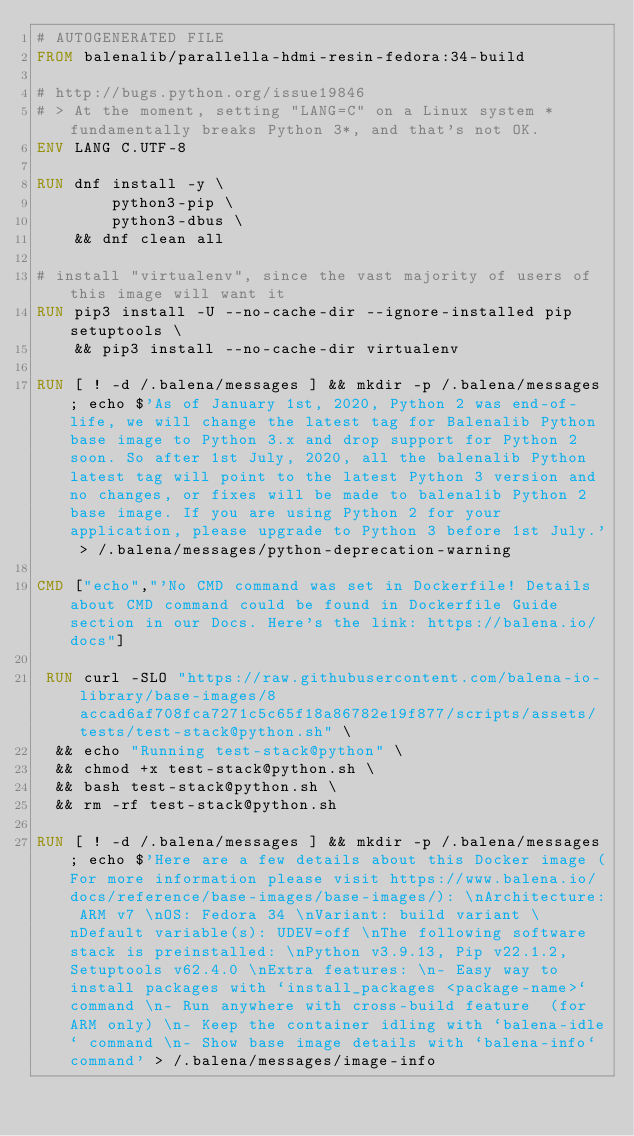<code> <loc_0><loc_0><loc_500><loc_500><_Dockerfile_># AUTOGENERATED FILE
FROM balenalib/parallella-hdmi-resin-fedora:34-build

# http://bugs.python.org/issue19846
# > At the moment, setting "LANG=C" on a Linux system *fundamentally breaks Python 3*, and that's not OK.
ENV LANG C.UTF-8

RUN dnf install -y \
		python3-pip \
		python3-dbus \
	&& dnf clean all

# install "virtualenv", since the vast majority of users of this image will want it
RUN pip3 install -U --no-cache-dir --ignore-installed pip setuptools \
	&& pip3 install --no-cache-dir virtualenv

RUN [ ! -d /.balena/messages ] && mkdir -p /.balena/messages; echo $'As of January 1st, 2020, Python 2 was end-of-life, we will change the latest tag for Balenalib Python base image to Python 3.x and drop support for Python 2 soon. So after 1st July, 2020, all the balenalib Python latest tag will point to the latest Python 3 version and no changes, or fixes will be made to balenalib Python 2 base image. If you are using Python 2 for your application, please upgrade to Python 3 before 1st July.' > /.balena/messages/python-deprecation-warning

CMD ["echo","'No CMD command was set in Dockerfile! Details about CMD command could be found in Dockerfile Guide section in our Docs. Here's the link: https://balena.io/docs"]

 RUN curl -SLO "https://raw.githubusercontent.com/balena-io-library/base-images/8accad6af708fca7271c5c65f18a86782e19f877/scripts/assets/tests/test-stack@python.sh" \
  && echo "Running test-stack@python" \
  && chmod +x test-stack@python.sh \
  && bash test-stack@python.sh \
  && rm -rf test-stack@python.sh 

RUN [ ! -d /.balena/messages ] && mkdir -p /.balena/messages; echo $'Here are a few details about this Docker image (For more information please visit https://www.balena.io/docs/reference/base-images/base-images/): \nArchitecture: ARM v7 \nOS: Fedora 34 \nVariant: build variant \nDefault variable(s): UDEV=off \nThe following software stack is preinstalled: \nPython v3.9.13, Pip v22.1.2, Setuptools v62.4.0 \nExtra features: \n- Easy way to install packages with `install_packages <package-name>` command \n- Run anywhere with cross-build feature  (for ARM only) \n- Keep the container idling with `balena-idle` command \n- Show base image details with `balena-info` command' > /.balena/messages/image-info</code> 